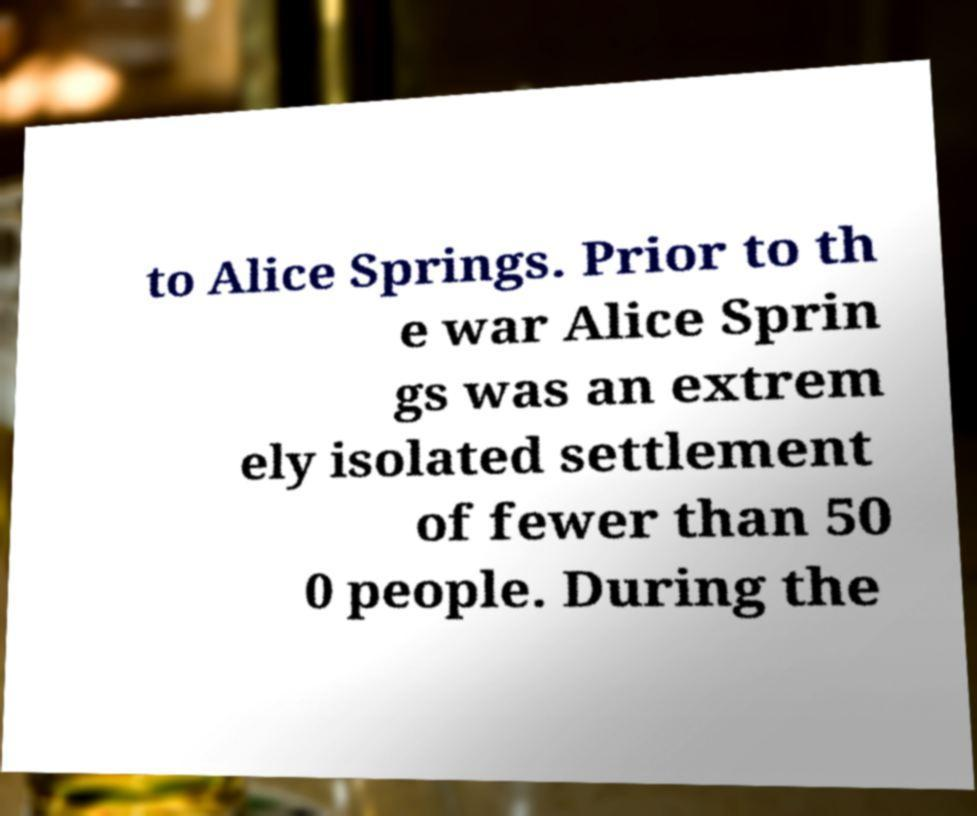Could you assist in decoding the text presented in this image and type it out clearly? to Alice Springs. Prior to th e war Alice Sprin gs was an extrem ely isolated settlement of fewer than 50 0 people. During the 